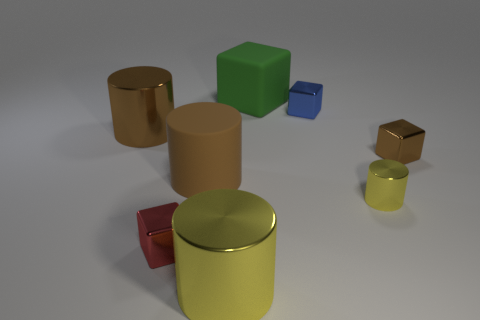Subtract 1 cubes. How many cubes are left? 3 Add 1 brown metallic spheres. How many objects exist? 9 Subtract 0 green cylinders. How many objects are left? 8 Subtract all small brown metal things. Subtract all blue metallic cubes. How many objects are left? 6 Add 4 big brown metallic objects. How many big brown metallic objects are left? 5 Add 3 shiny blocks. How many shiny blocks exist? 6 